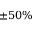<formula> <loc_0><loc_0><loc_500><loc_500>\pm 5 0 \%</formula> 